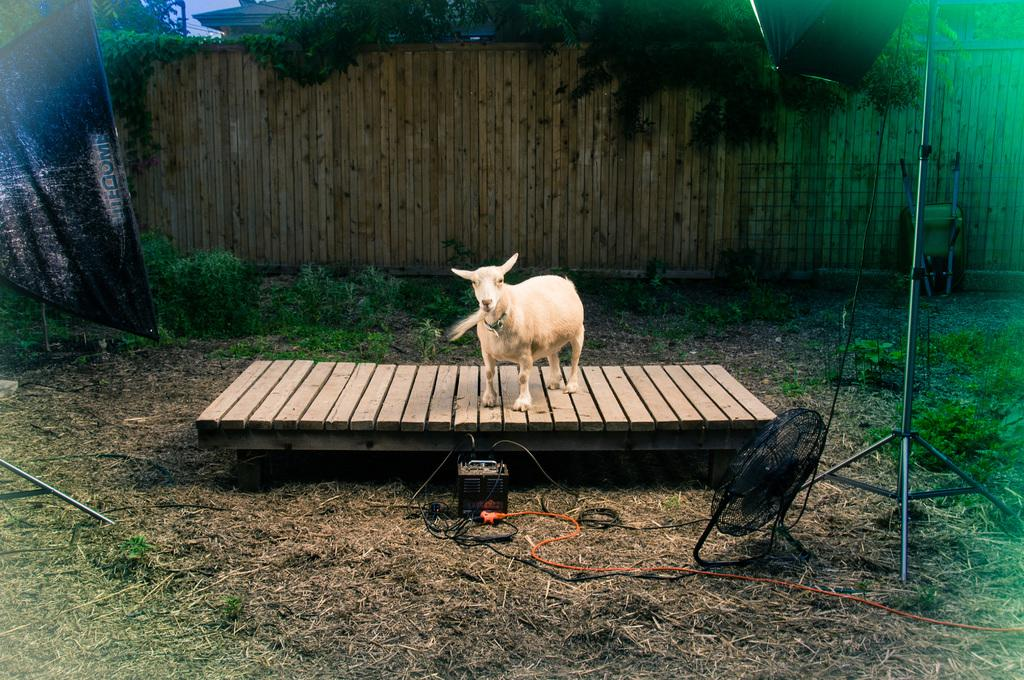What appliance can be seen in the image? There is a fan in the image. What type of animal is present in the image? There is a white-colored goat in the image. What objects are made of wood in the image? There are wooden sticks in the image. What type of plant is visible in the image? There is a tree in the image. What type of agreement was reached in the image? There is no indication of an agreement or discussion in the image; it features a fan, a white-colored goat, wooden sticks, and a tree. What knowledge is being shared in the image? There is no indication of knowledge being shared or taught in the image; it features a fan, a white-colored goat, wooden sticks, and a tree. 